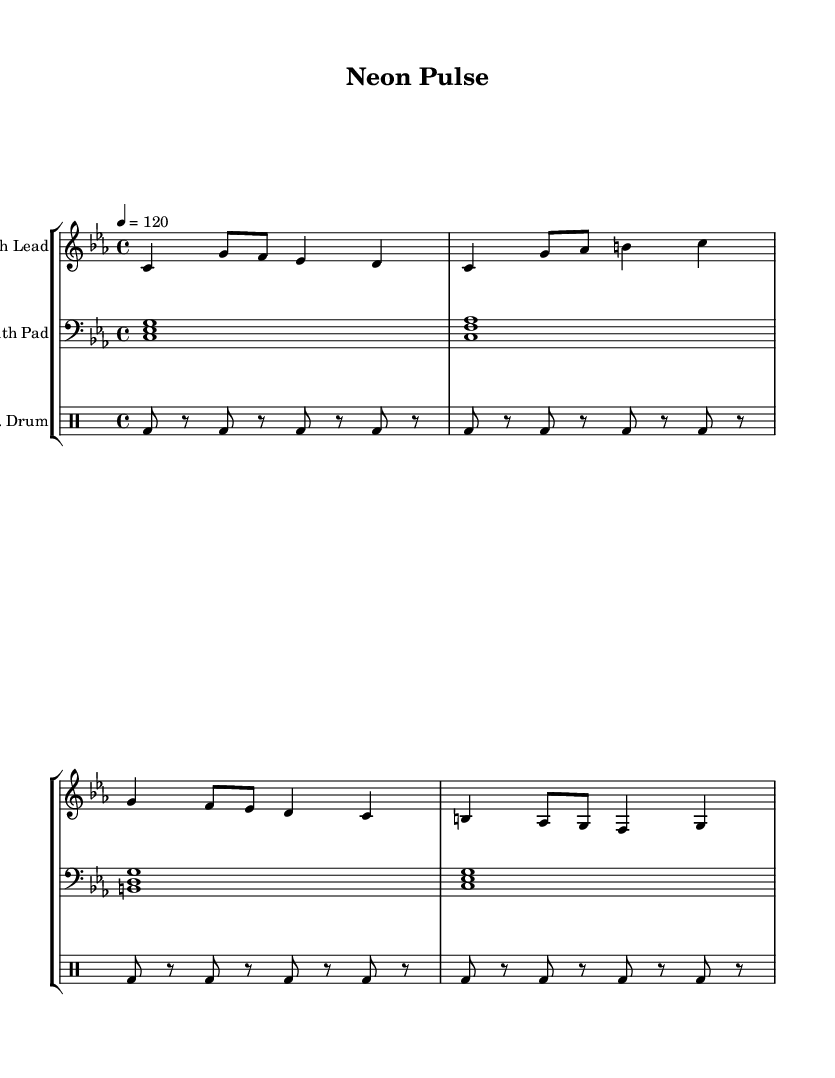What is the key signature of this music? The key signature is C minor, which has three flats (B♭, E♭, A♭).
Answer: C minor What is the time signature of this piece? The time signature is found at the beginning of the score as 4/4, which indicates four beats in a measure and a quarter note gets one beat.
Answer: 4/4 What is the tempo marking for this score? The tempo marking indicates that the piece should be played at a speed of 120 beats per minute, which is noted at the beginning with "4 = 120".
Answer: 120 How many measures are there in the synth lead section? The synth lead section contains four measures, indicated by the grouping of the notes and the end of each line corresponds to a measure.
Answer: 4 Which instrument has the bass clef? The bass clef is used by the synth pad, as indicated at the start of its staff, distinguishing it from the treble clef used by the synth lead.
Answer: Synth Pad What type of drum pattern is used in the electronic drum part? The electronic drum part consists of a bass drum pattern, specifically a repeated eight-note bass drum hit followed by rests, providing a driving rhythmic foundation for the piece.
Answer: Bass drum What is the function of the synth pad in this score? The synth pad primarily provides harmonic support and sustains chords throughout the piece, indicated by the use of sustained notes and specific chord voicings in the bass clef.
Answer: Harmonic support 